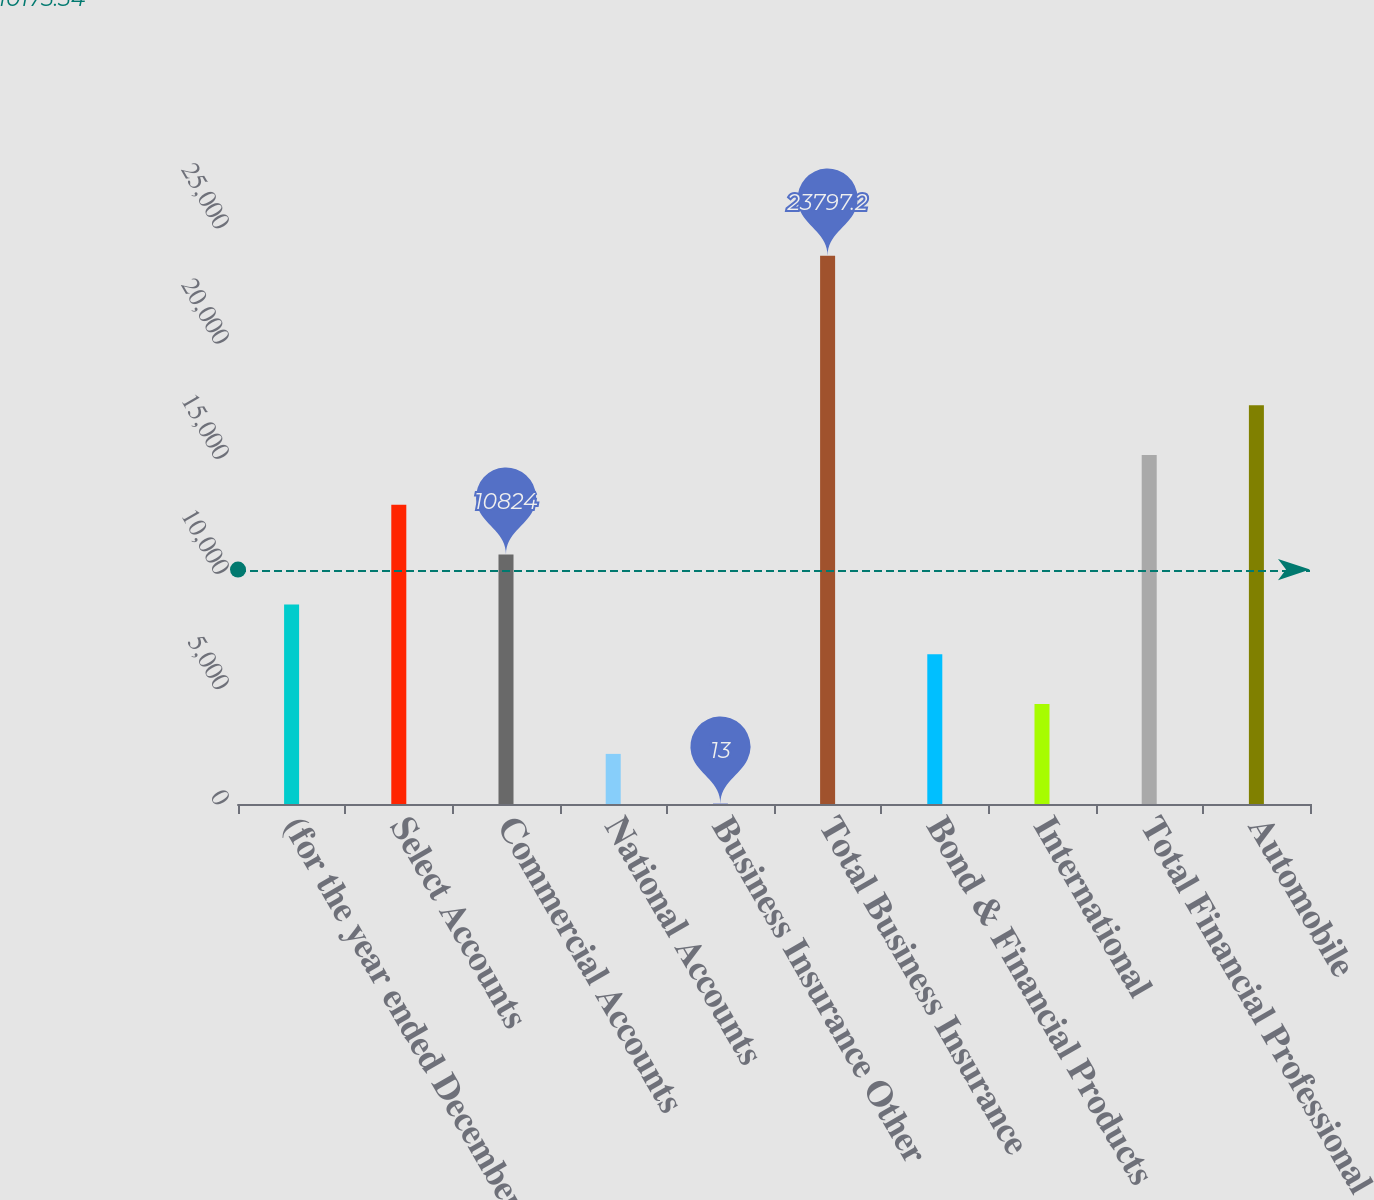<chart> <loc_0><loc_0><loc_500><loc_500><bar_chart><fcel>(for the year ended December<fcel>Select Accounts<fcel>Commercial Accounts<fcel>National Accounts<fcel>Business Insurance Other<fcel>Total Business Insurance<fcel>Bond & Financial Products<fcel>International<fcel>Total Financial Professional &<fcel>Automobile<nl><fcel>8661.8<fcel>12986.2<fcel>10824<fcel>2175.2<fcel>13<fcel>23797.2<fcel>6499.6<fcel>4337.4<fcel>15148.4<fcel>17310.6<nl></chart> 